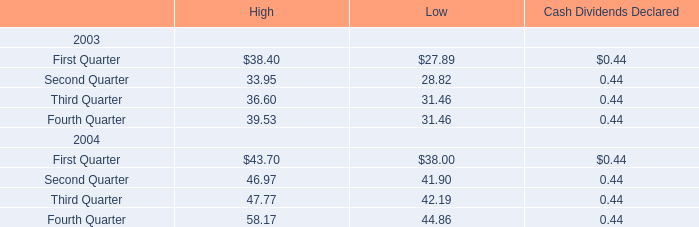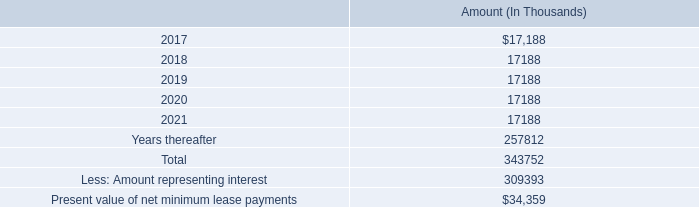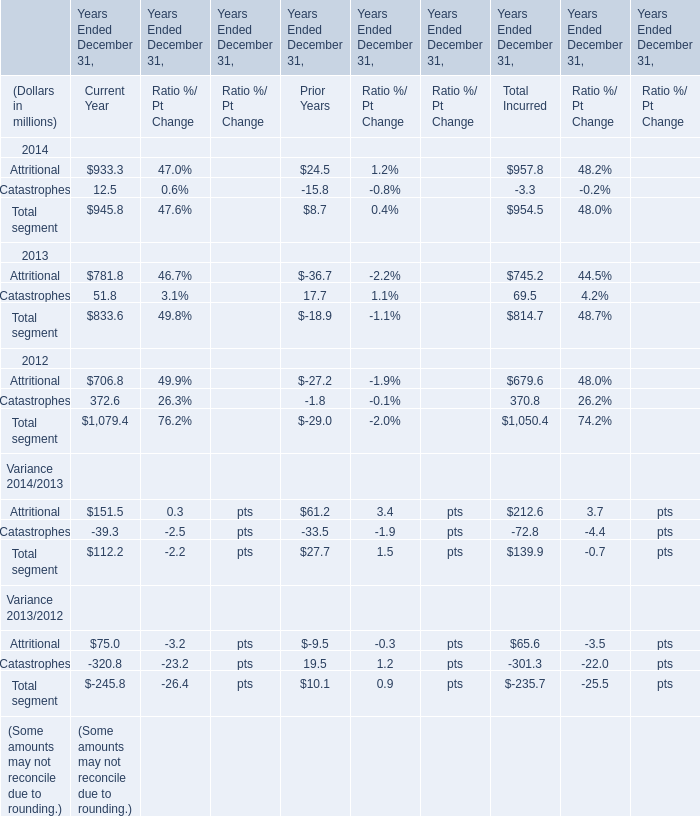What was the total amount of the Catastrophes in the years where Attritional for Total Incurred greater than 900? (in million) 
Computations: (12.5 - 15.8)
Answer: -3.3. 